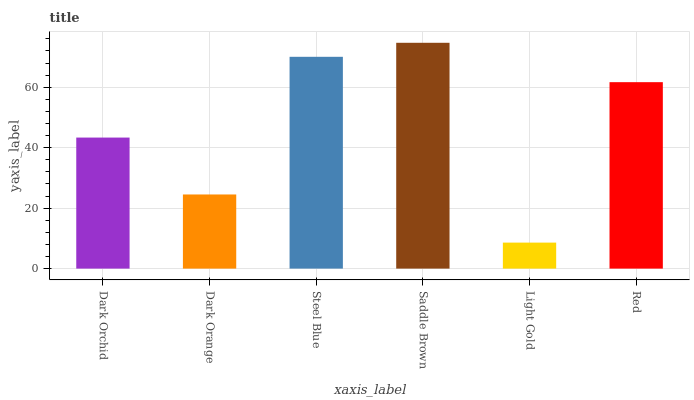Is Light Gold the minimum?
Answer yes or no. Yes. Is Saddle Brown the maximum?
Answer yes or no. Yes. Is Dark Orange the minimum?
Answer yes or no. No. Is Dark Orange the maximum?
Answer yes or no. No. Is Dark Orchid greater than Dark Orange?
Answer yes or no. Yes. Is Dark Orange less than Dark Orchid?
Answer yes or no. Yes. Is Dark Orange greater than Dark Orchid?
Answer yes or no. No. Is Dark Orchid less than Dark Orange?
Answer yes or no. No. Is Red the high median?
Answer yes or no. Yes. Is Dark Orchid the low median?
Answer yes or no. Yes. Is Dark Orchid the high median?
Answer yes or no. No. Is Dark Orange the low median?
Answer yes or no. No. 